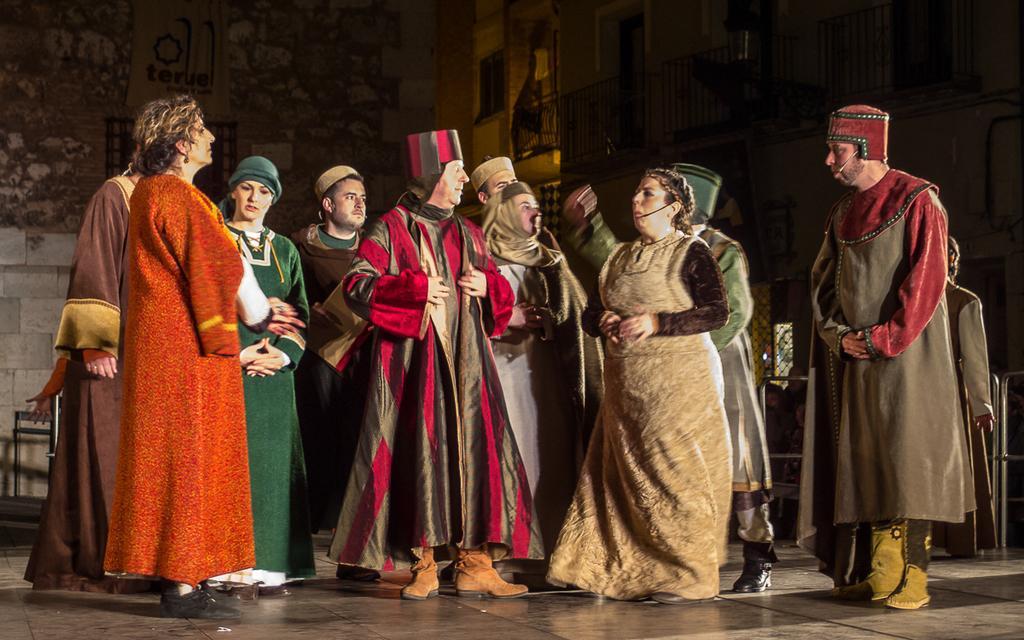How would you summarize this image in a sentence or two? In this image we can see women and men are standing. They are wearing some kind of costumes and mic. Behind the building is present. 